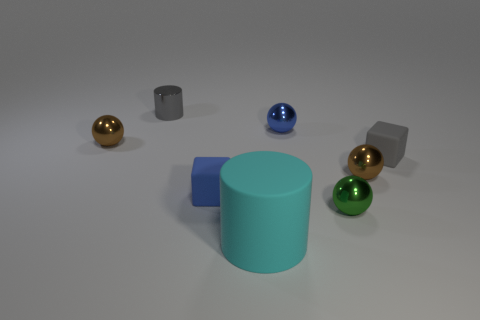Subtract all cyan cylinders. Subtract all red blocks. How many cylinders are left? 1 Add 1 green balls. How many objects exist? 9 Subtract all cylinders. How many objects are left? 6 Subtract 0 red cylinders. How many objects are left? 8 Subtract all brown metallic balls. Subtract all tiny brown balls. How many objects are left? 4 Add 4 blue matte objects. How many blue matte objects are left? 5 Add 3 large purple matte cylinders. How many large purple matte cylinders exist? 3 